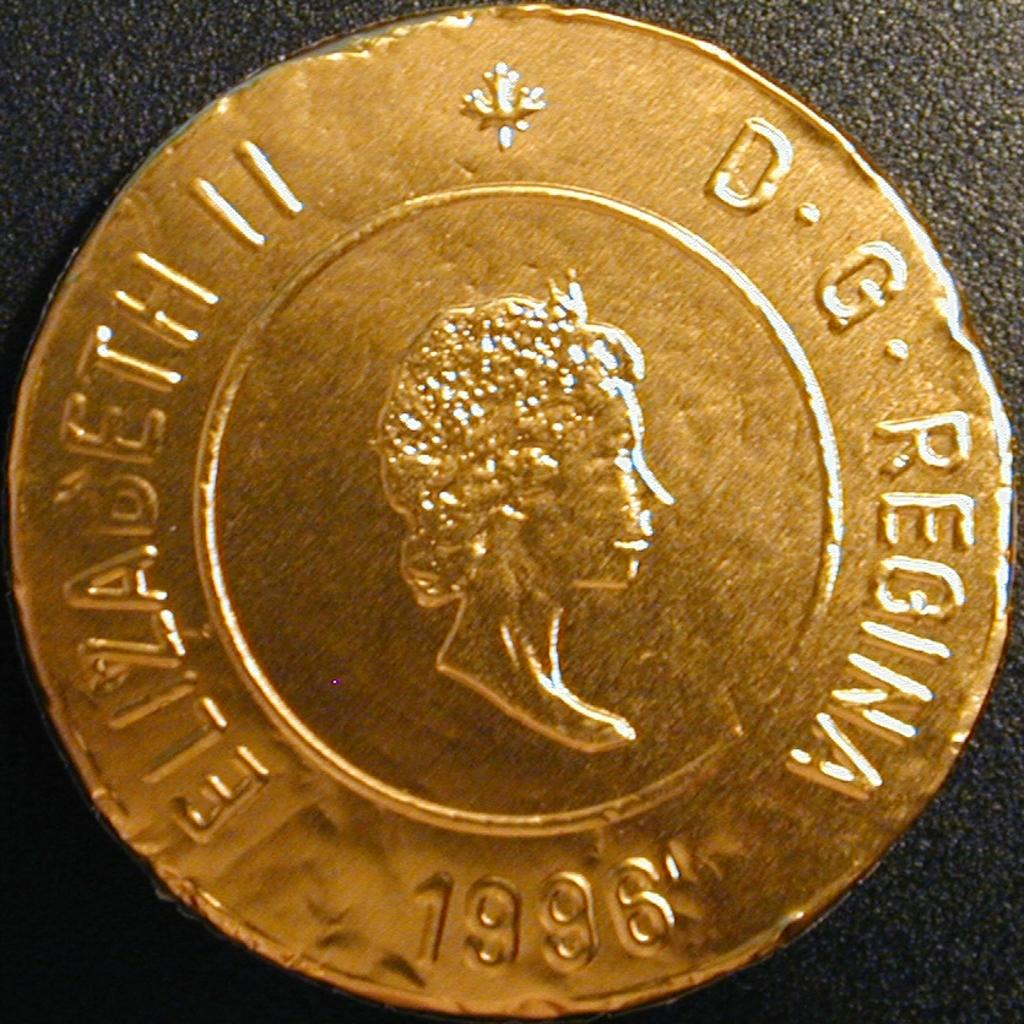What object is visible in the image? There is a coin in the image. Can you describe the position of the coin in the image? The coin is placed on a surface. Where can you find the market where the coin was purchased in the image? There is no market present in the image, as it only features a coin placed on a surface. What type of sticks are used to smash the coin in the image? There are no sticks or any action of smashing the coin in the image. 